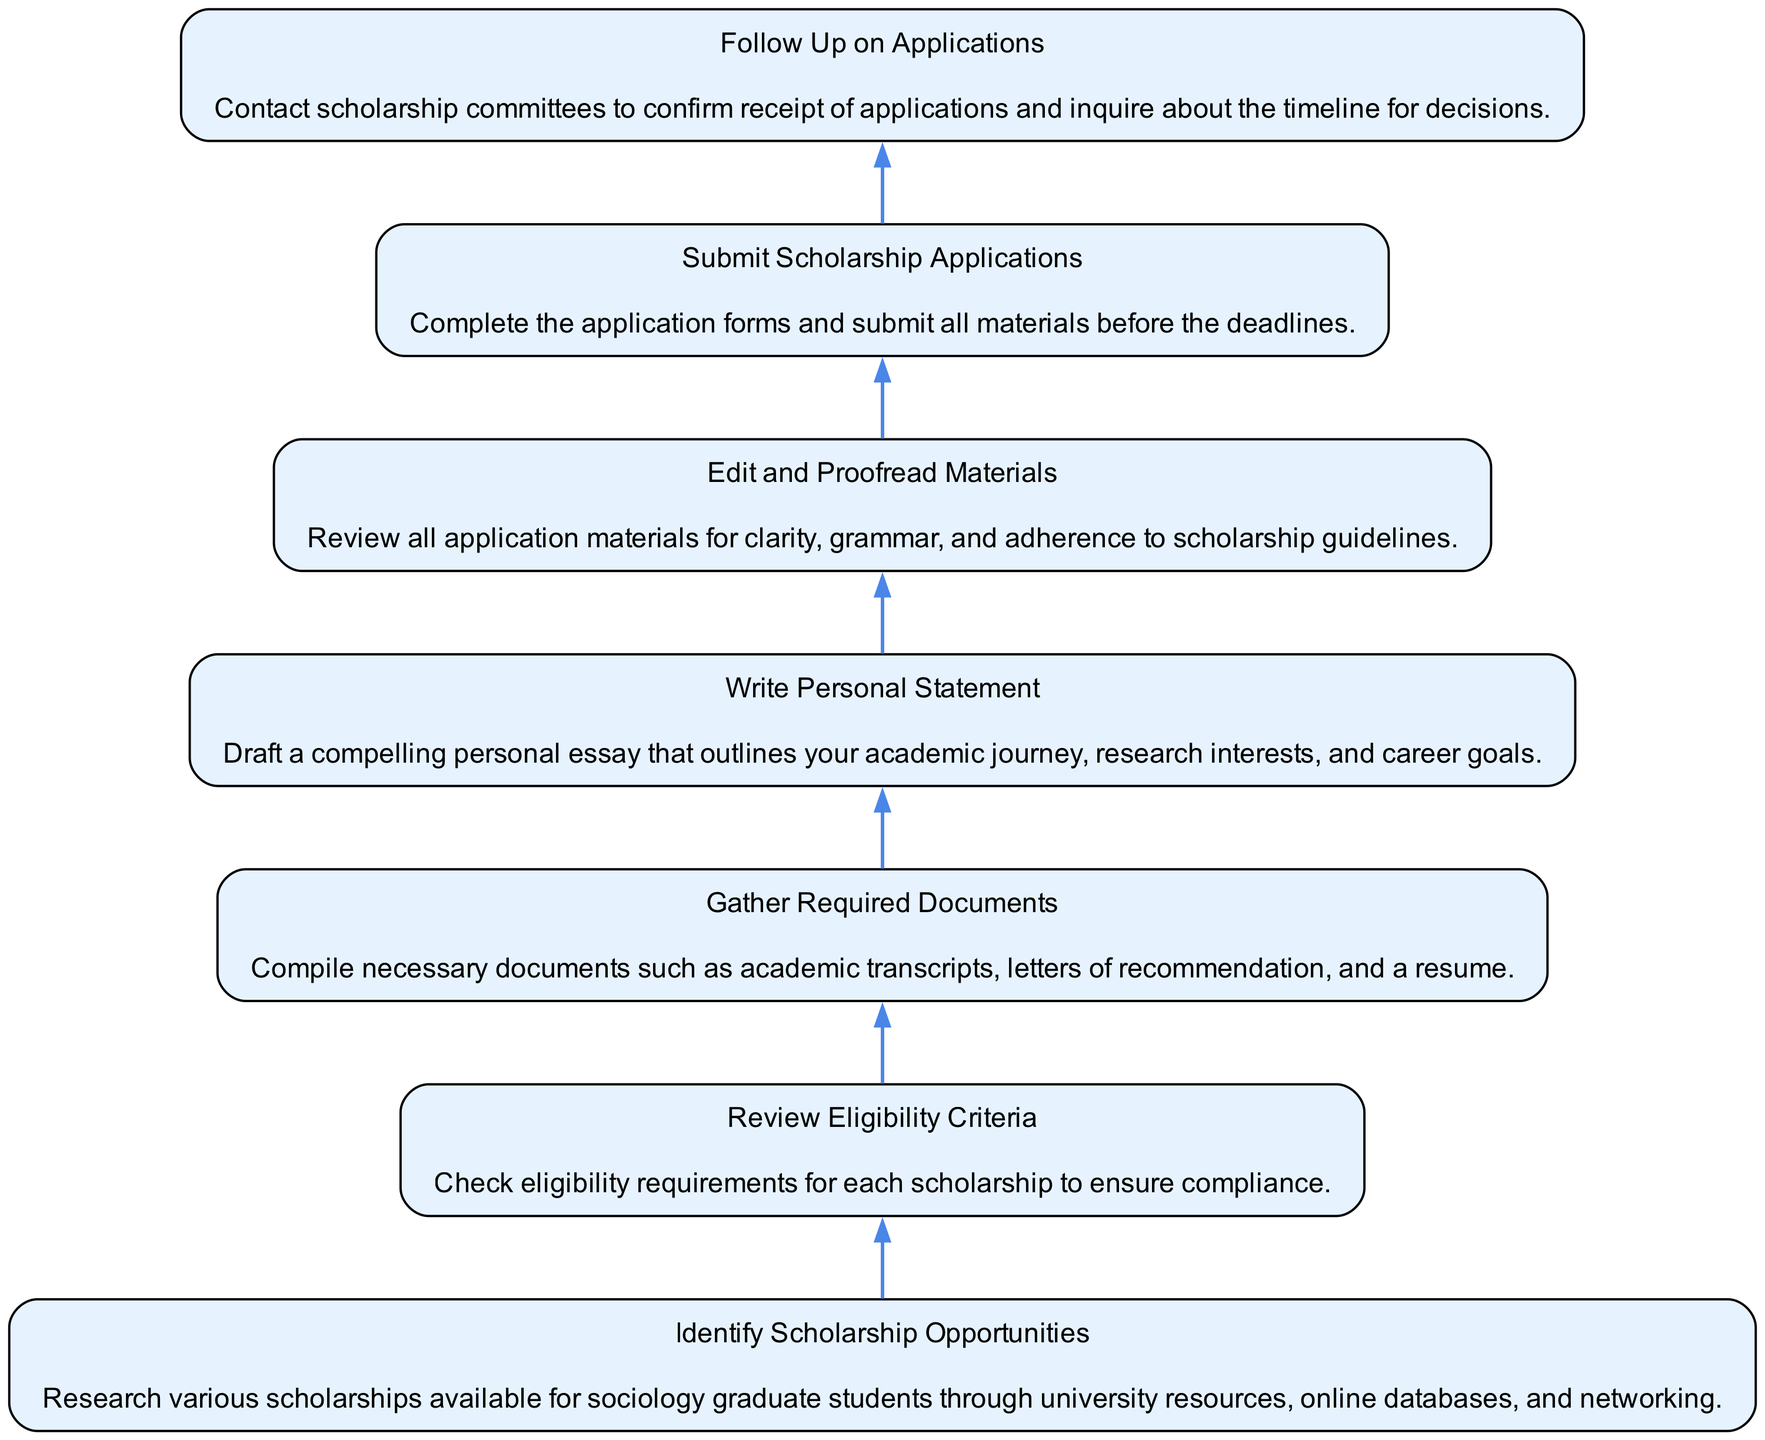What is the first step in the scholarship application process? The first step is "Identify Scholarship Opportunities," which is presented at the bottom of the flowchart. This indicates that one must begin by researching various scholarships available for sociology graduate students.
Answer: Identify Scholarship Opportunities How many total nodes are in the diagram? Upon counting the listed elements in the flowchart, we find there are seven nodes representing different steps in the scholarship application process.
Answer: 7 What comes after "Gather Required Documents"? The step that follows "Gather Required Documents" is "Write Personal Statement," indicating that after collecting documents, the next action is to draft the essay.
Answer: Write Personal Statement What is the purpose of "Edit and Proofread Materials"? The purpose of this step is to review all application materials for clarity, grammar, and adherence to scholarship guidelines, as stated in the diagram.
Answer: Review all application materials Which step includes contacting scholarship committees? The last step of "Follow Up on Applications" involves contacting scholarship committees to confirm receipt of applications and inquire about decision timelines.
Answer: Follow Up on Applications Is there a step that involves writing? Yes, the diagram clearly includes a step called "Write Personal Statement," which specifically involves drafting a personal essay regarding academic journey and career goals.
Answer: Write Personal Statement What is the last step in the application process? The last step, as shown in the diagram, is "Follow Up on Applications," indicating that this is the final action you should take after submitting applications.
Answer: Follow Up on Applications 